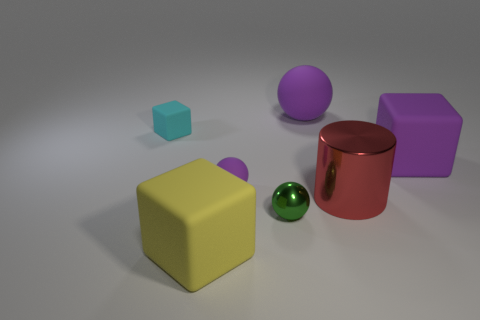What number of other objects are there of the same size as the purple matte cube?
Your answer should be compact. 3. The rubber cube that is the same color as the big ball is what size?
Provide a succinct answer. Large. There is a tiny sphere behind the tiny metallic thing; what is its color?
Make the answer very short. Purple. There is a big shiny cylinder; is its color the same as the matte object to the right of the cylinder?
Make the answer very short. No. Are there fewer matte things than red things?
Your answer should be very brief. No. Is the color of the big block that is on the left side of the green thing the same as the big metallic thing?
Your response must be concise. No. How many other spheres are the same size as the shiny ball?
Your response must be concise. 1. Is there a block that has the same color as the cylinder?
Ensure brevity in your answer.  No. Is the material of the purple block the same as the large cylinder?
Give a very brief answer. No. What number of other small matte objects are the same shape as the small cyan object?
Your answer should be very brief. 0. 